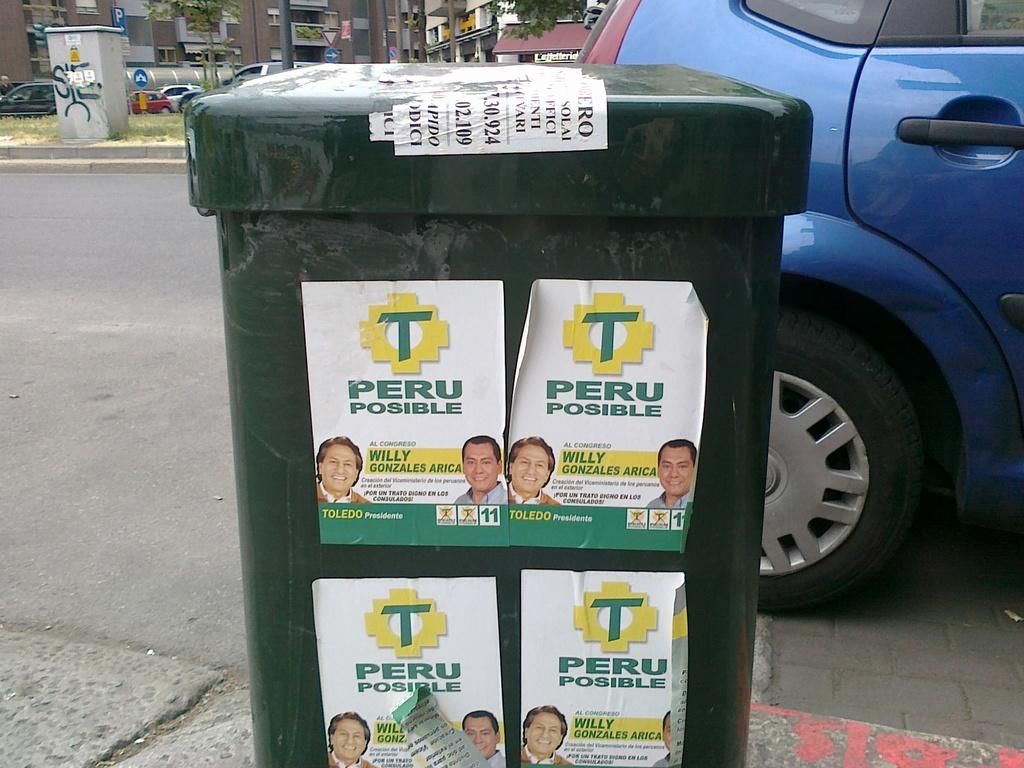<image>
Offer a succinct explanation of the picture presented. Several Peru Possible posters on a green trash can on the street. 